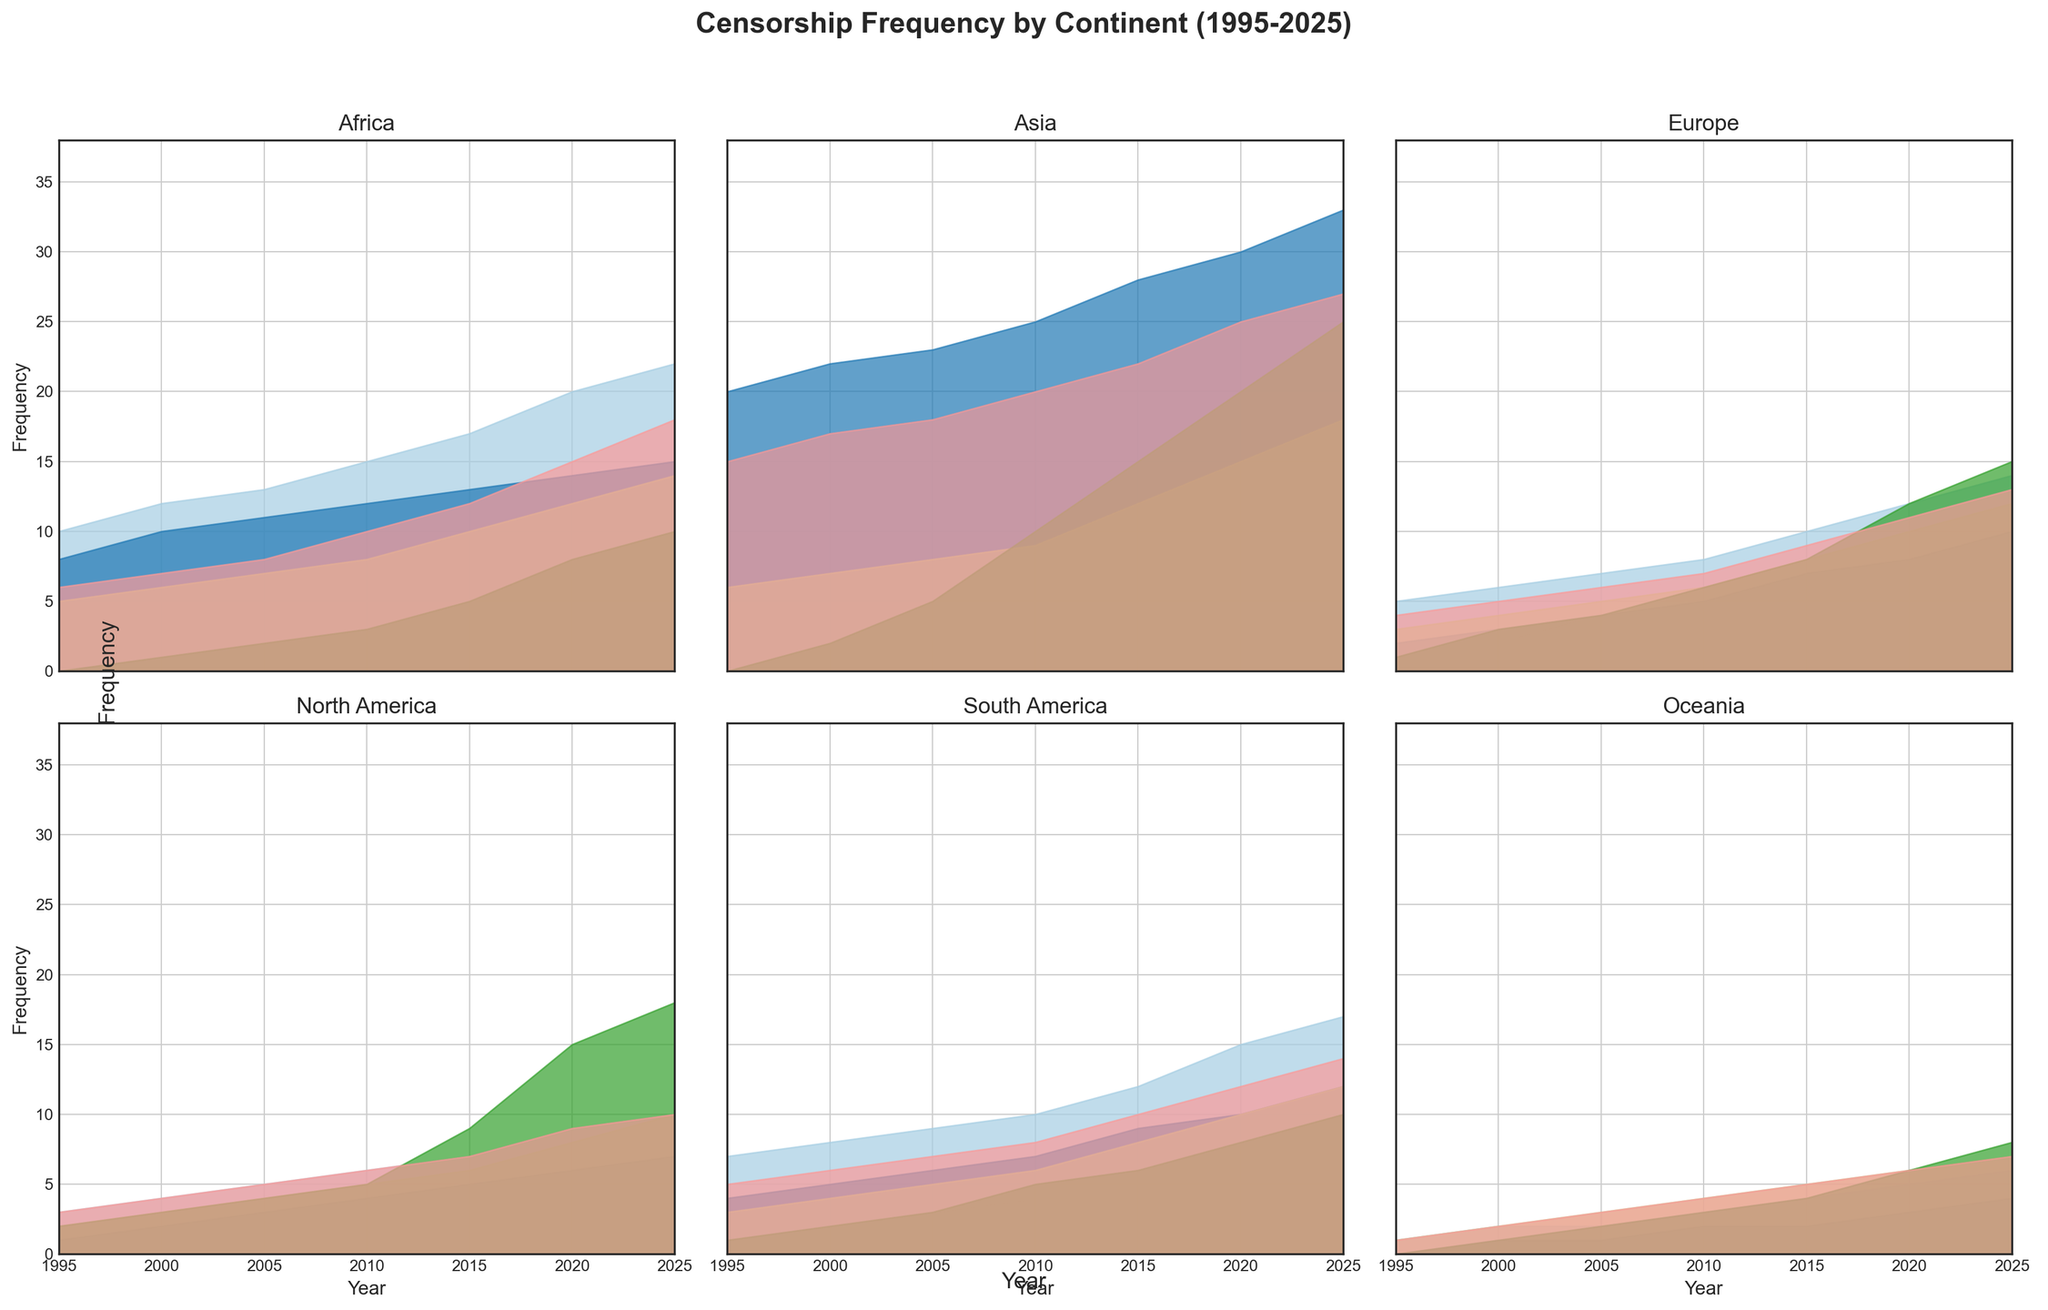Which continent had the highest frequency of Social Media Censorship in 2025? Observe the height of the area representing Social Media Censorship for each continent in 2025. Asia has the highest peak in this category.
Answer: Asia What is the difference in the frequency of Political Censorship between Africa and Europe in 2020? Find the height of the Political Censorship area for both Africa and Europe for the year 2020. Africa has a frequency of 20 and Europe has a frequency of 12. Subtract the European frequency from the African frequency: 20 - 12.
Answer: 8 Which type of censorship saw the most significant increase in Asia from 1995 to 2025? Compare the heights of the areas representing the different types of censorship in Asia for the years 1995 and 2025. Social Media Censorship shows a significant increase from 0 to 25.
Answer: Social Media Censorship How does the 2005 frequency of Religious Censorship in South America compare to that in Oceania? Look at the height of the Religious Censorship area for South America and Oceania in 2005. South America has a value of 6, while Oceania has a value of 1. 6 is greater than 1.
Answer: South America is greater In 2015, which continent has the lowest frequency in Cultural Censorship? Observe the heights representing Cultural Censorship for each continent in 2015. Oceania has the lowest height in this category with a frequency of 5.
Answer: Oceania Which continent showed the most significant increase in Anti-Government Censorship between 1995 and 2025? Compare the heights of the Anti-Government Censorship areas in 1995 and 2025 for each continent. Asia shows the most significant increase, from 15 to 27.
Answer: Asia Between 2000 and 2020, which type of censorship increased the most in North America? Observe the areas representing different types of censorship for North America between 2000 and 2020. Social Media Censorship shows an increase from 3 to 15, which is the most significant.
Answer: Social Media Censorship How many more instances of Religious Censorship were there in Africa in 2025 compared to 1995? Calculate the difference in the heights of the Religious Censorship area for Africa between 1995 (8) and 2025 (15). 15 - 8 = 7.
Answer: 7 What is the total frequency of all types of censorship in Oceania in 2025? Find the sum of the heights of all the censorship areas for Oceania in 2025: Political (6) + Religious (4) + Cultural (7) + Social Media (8) + Anti-Government (7). 6 + 4 + 7 + 8 + 7 = 32.
Answer: 32 What was the trend in Social Media Censorship in Europe between 1995 and 2025? Observe the changes in the height of the Social Media Censorship area for Europe from 1995 to 2025. It increased from 1 in 1995 to 15 in 2025, indicating a rising trend.
Answer: Rising trend 